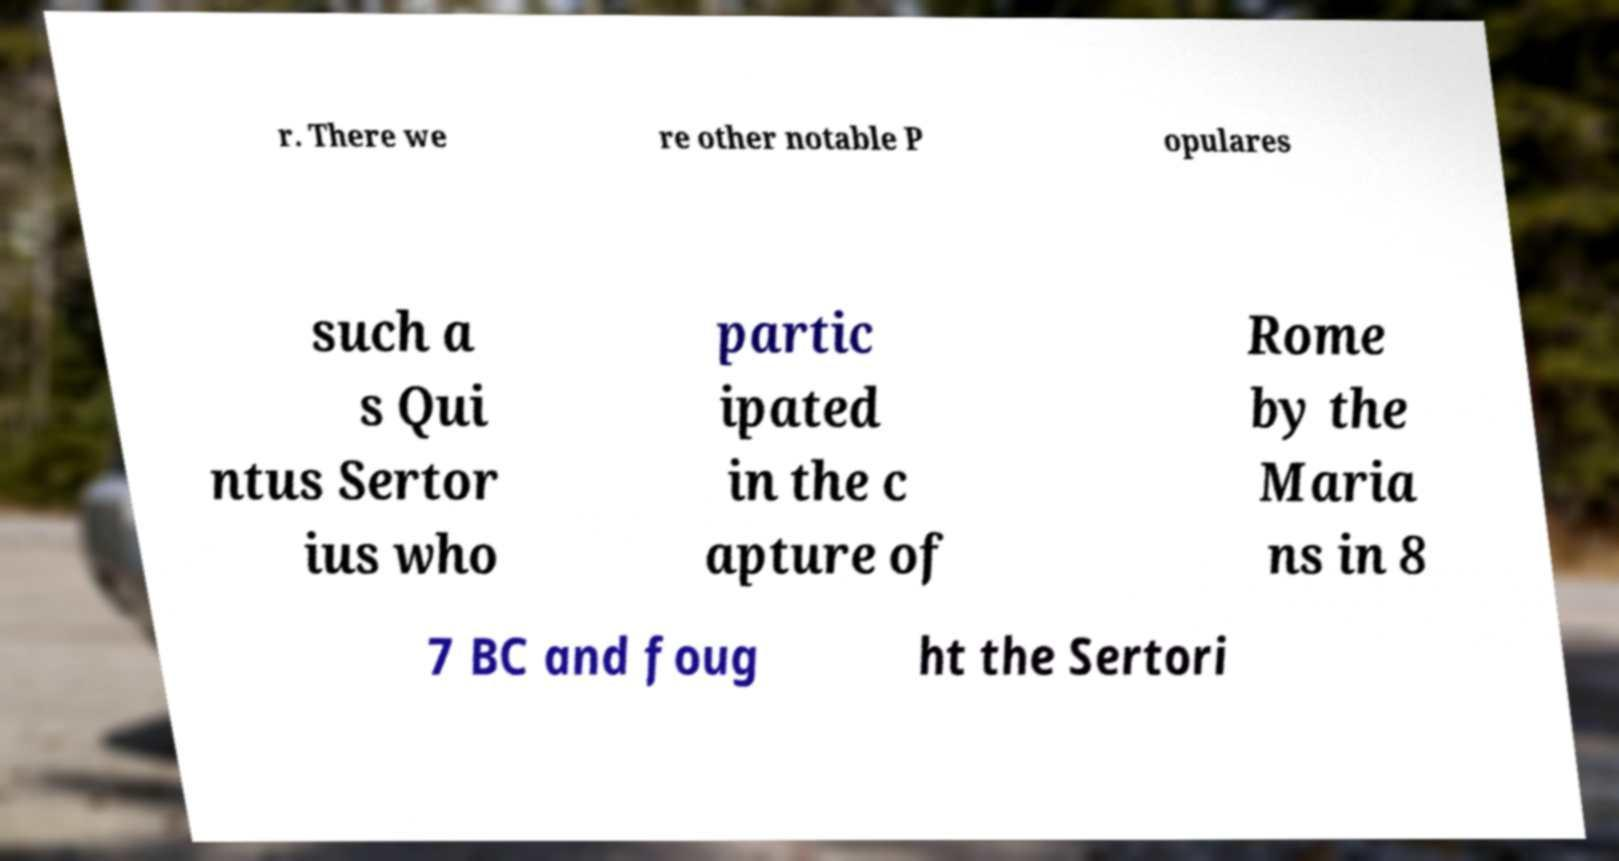Can you accurately transcribe the text from the provided image for me? r. There we re other notable P opulares such a s Qui ntus Sertor ius who partic ipated in the c apture of Rome by the Maria ns in 8 7 BC and foug ht the Sertori 